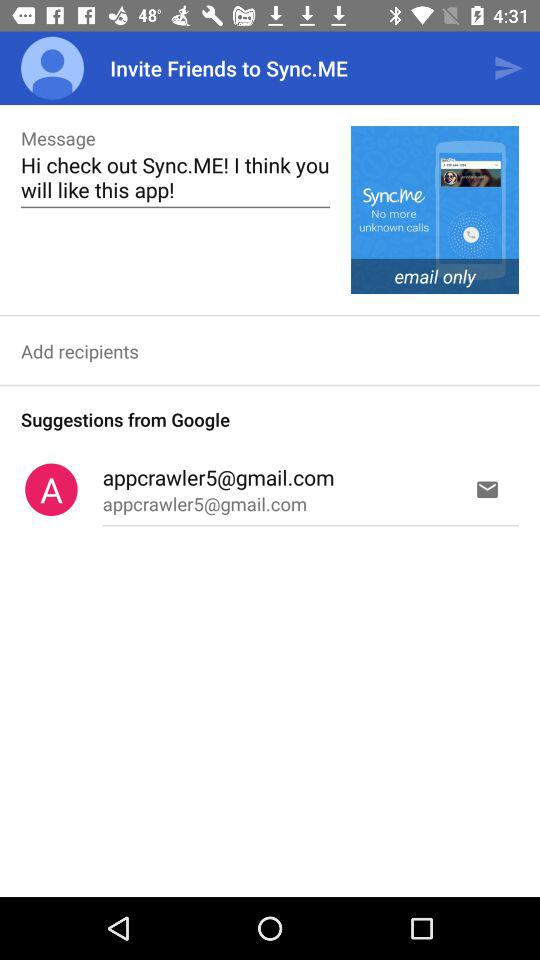What email address is given in the suggestions? The given email address in the suggestions is appcrawler5@gmail.com. 